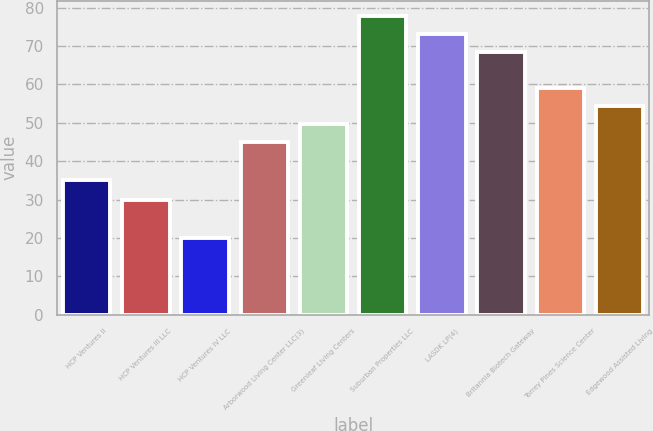<chart> <loc_0><loc_0><loc_500><loc_500><bar_chart><fcel>HCP Ventures II<fcel>HCP Ventures III LLC<fcel>HCP Ventures IV LLC<fcel>Arborwood Living Center LLC(3)<fcel>Greenleaf Living Centers<fcel>Suburban Properties LLC<fcel>LASDK LP(4)<fcel>Britannia Biotech Gateway<fcel>Torrey Pines Science Center<fcel>Edgewood Assisted Living<nl><fcel>35<fcel>30<fcel>20<fcel>45<fcel>49.7<fcel>77.9<fcel>73.2<fcel>68.5<fcel>59.1<fcel>54.4<nl></chart> 